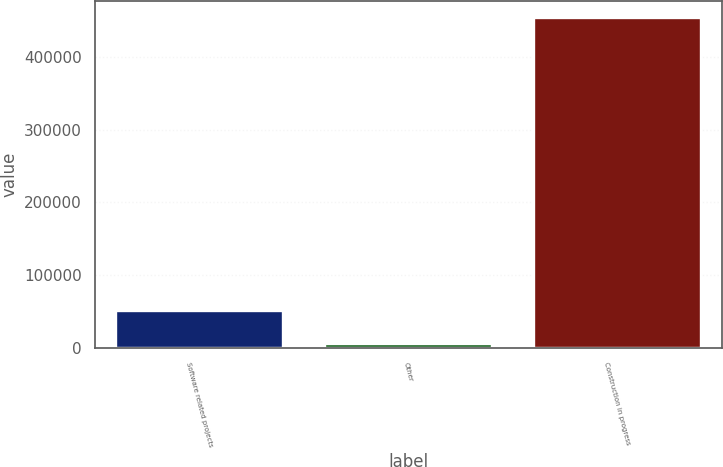Convert chart. <chart><loc_0><loc_0><loc_500><loc_500><bar_chart><fcel>Software related projects<fcel>Other<fcel>Construction in progress<nl><fcel>50945.9<fcel>6246<fcel>453245<nl></chart> 